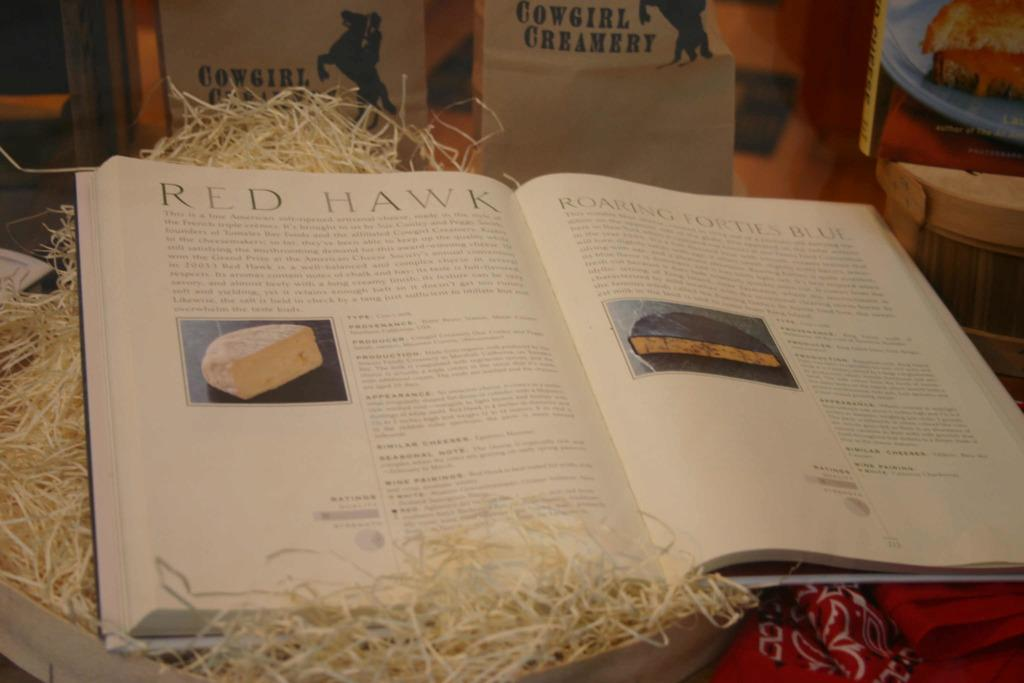<image>
Render a clear and concise summary of the photo. an open book with the page titled 'Red Hawk' 